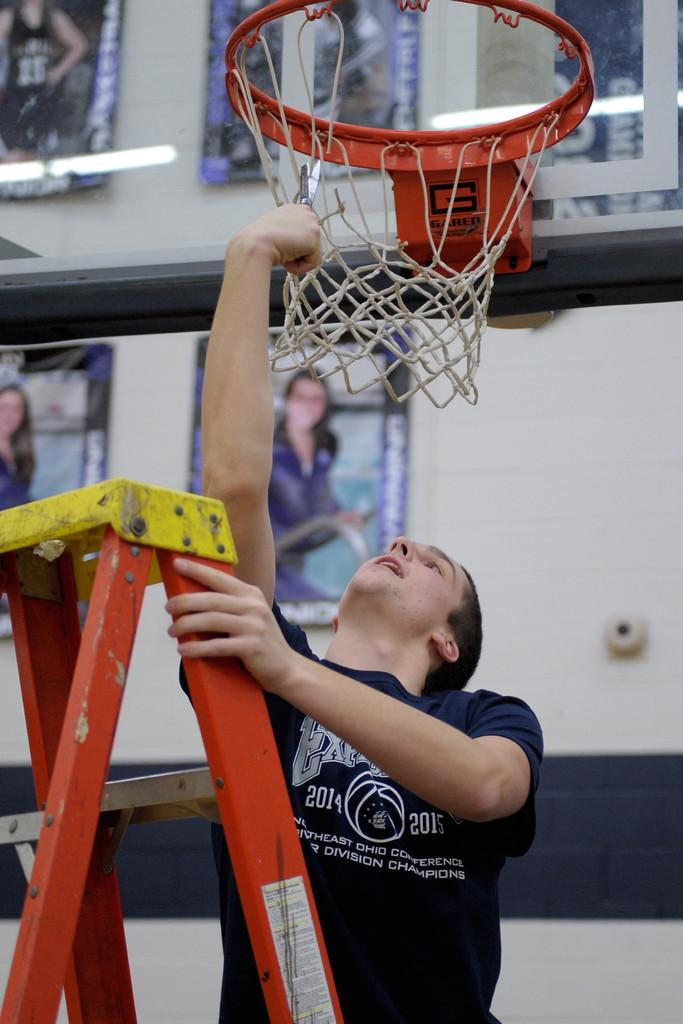<image>
Create a compact narrative representing the image presented. A man fixing a basketball net is wearing a shirt with the date 2014 on it. 